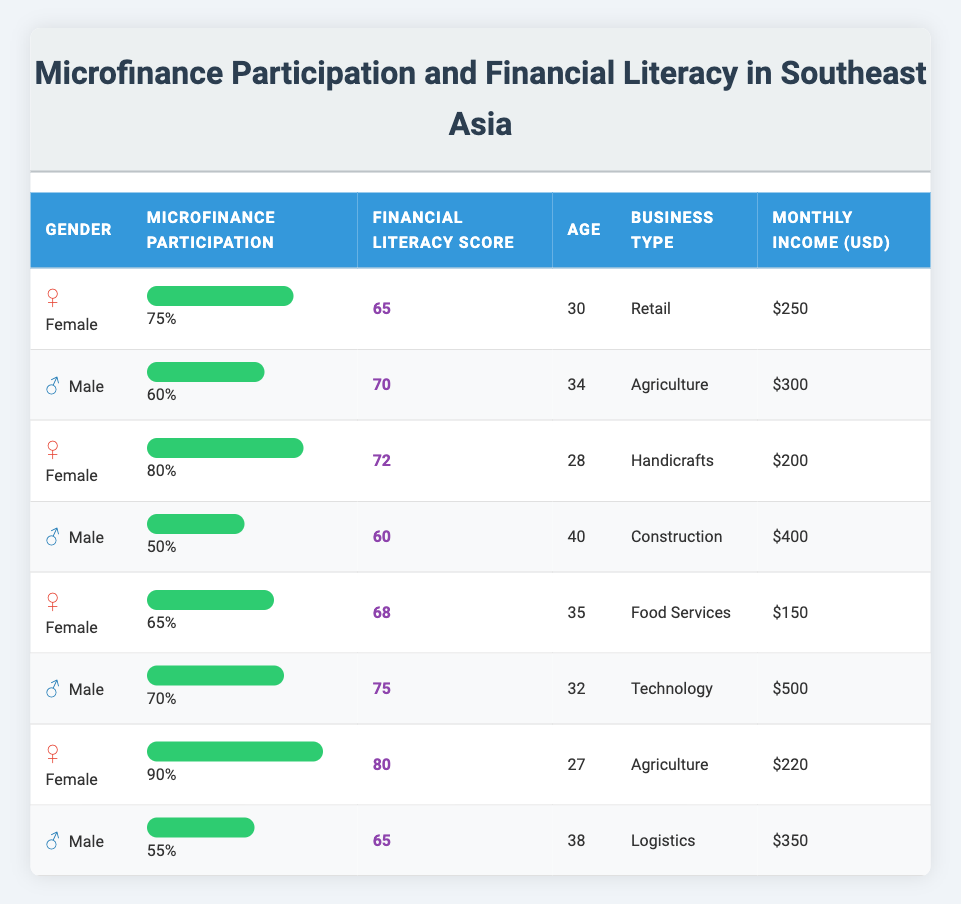What is the financial literacy score of the female participant with the highest microfinance participation? The female participant with the highest microfinance participation is the one with 90% participation. In the table, the corresponding financial literacy score for this participant is 80.
Answer: 80 What is the average monthly income of male participants? To find the average monthly income of male participants, we need to add up their monthly incomes: 300 + 400 + 500 + 350 = 1550. There are 4 male participants, so the average income is 1550/4 = 387.5.
Answer: 387.5 Is the financial literacy score for the male participant in Technology higher than that of the male participant in Construction? The financial literacy score for the male participant in Technology is 75, while the score for the male participant in Construction is 60; therefore, 75 is indeed higher than 60.
Answer: Yes What is the total microfinance participation percentage of all female participants? The microfinance participation percentages of the female participants are 75%, 80%, 65%, and 90%. The total participation percentage is 75 + 80 + 65 + 90 = 310%. Since there are 4 female participants, the average is 310/4 = 77.5%.
Answer: 77.5% Which gender has a higher average financial literacy score? We need to calculate the average financial literacy score for both genders. For females, the scores are 65, 72, 68, and 80, summing to 285, which gives an average of 285/4 = 71.25. For males, the scores are 70, 60, 75, and 65, summing to 270, which gives an average of 270/4 = 67.5. Comparing both averages, 71.25 is higher than 67.5.
Answer: Female What is the difference in microfinance participation rates between the highest male and highest female participants? The highest female participation is 90%, and the highest male participation is 70%. We calculate the difference by subtracting the lower score from the higher score: 90 - 70 = 20%.
Answer: 20% How many female participants scored above 70 in financial literacy? The financial literacy scores for female participants are 65, 72, 68, and 80. Among these, the scores above 70 are 72 and 80, totaling 2 female participants.
Answer: 2 What is the overall microfinance participation rate? The participation rates are 75%, 60%, 80%, 50%, 65%, 70%, 90%, and 55%. Summing these gives 75 + 60 + 80 + 50 + 65 + 70 + 90 + 55 = 590%. There are 8 participants, so the overall average participation rate is 590/8 = 73.75%.
Answer: 73.75% 